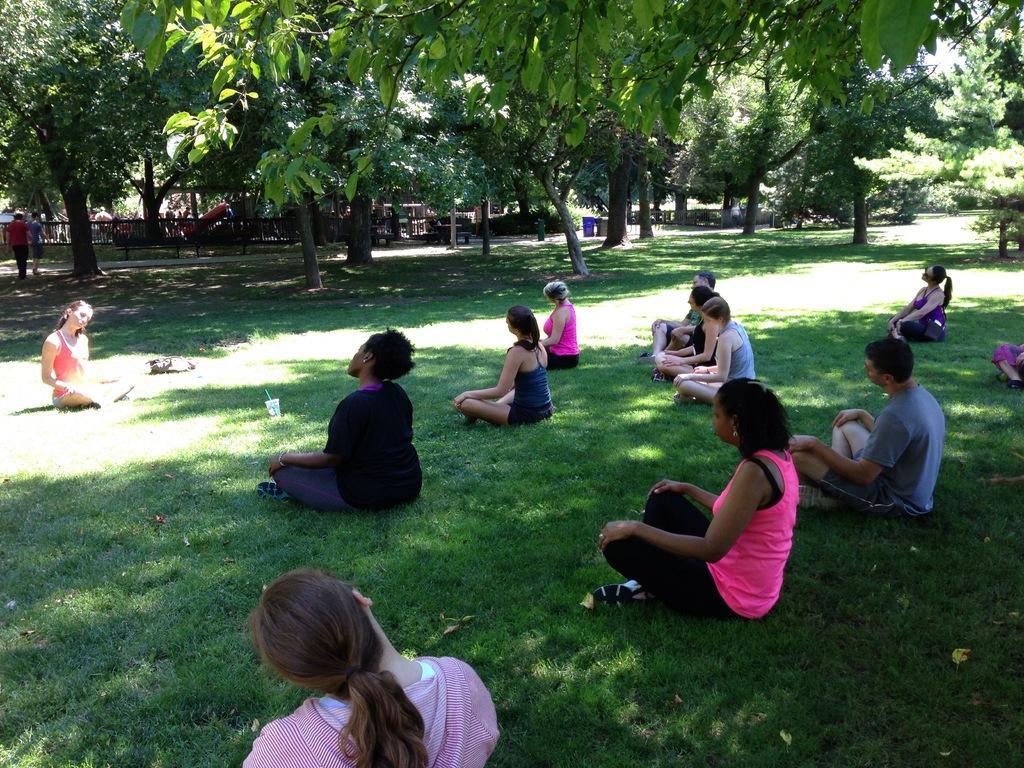How would you summarize this image in a sentence or two? In this picture, we see people sitting in the garden and are doing yoga. Behind them, we see an iron railing and people walking on the bridge. In the background, there are trees and a building. We even see garbage bin in blue color. This picture is clicked in the garden. 